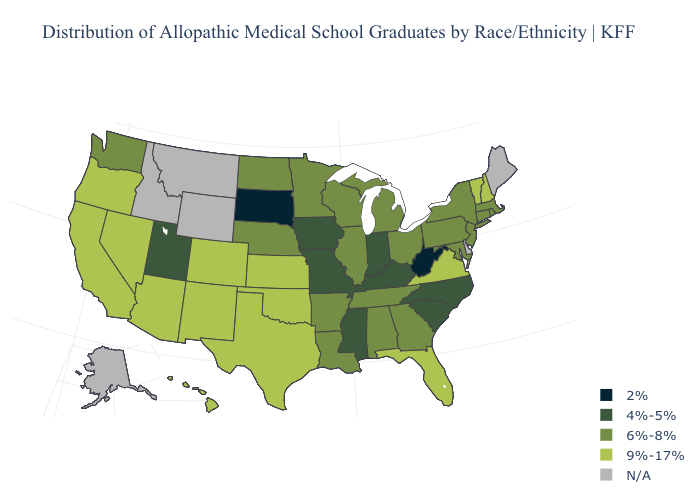Name the states that have a value in the range 2%?
Answer briefly. South Dakota, West Virginia. What is the value of Nevada?
Short answer required. 9%-17%. Name the states that have a value in the range 6%-8%?
Quick response, please. Alabama, Arkansas, Connecticut, Georgia, Illinois, Louisiana, Maryland, Massachusetts, Michigan, Minnesota, Nebraska, New Jersey, New York, North Dakota, Ohio, Pennsylvania, Rhode Island, Tennessee, Washington, Wisconsin. What is the highest value in the South ?
Concise answer only. 9%-17%. What is the value of Massachusetts?
Be succinct. 6%-8%. Does Rhode Island have the highest value in the Northeast?
Answer briefly. No. Name the states that have a value in the range 2%?
Write a very short answer. South Dakota, West Virginia. Does West Virginia have the lowest value in the USA?
Be succinct. Yes. Which states have the lowest value in the MidWest?
Short answer required. South Dakota. How many symbols are there in the legend?
Short answer required. 5. What is the lowest value in the USA?
Keep it brief. 2%. What is the lowest value in states that border North Dakota?
Short answer required. 2%. Name the states that have a value in the range 2%?
Write a very short answer. South Dakota, West Virginia. What is the highest value in the USA?
Be succinct. 9%-17%. Does the map have missing data?
Write a very short answer. Yes. 